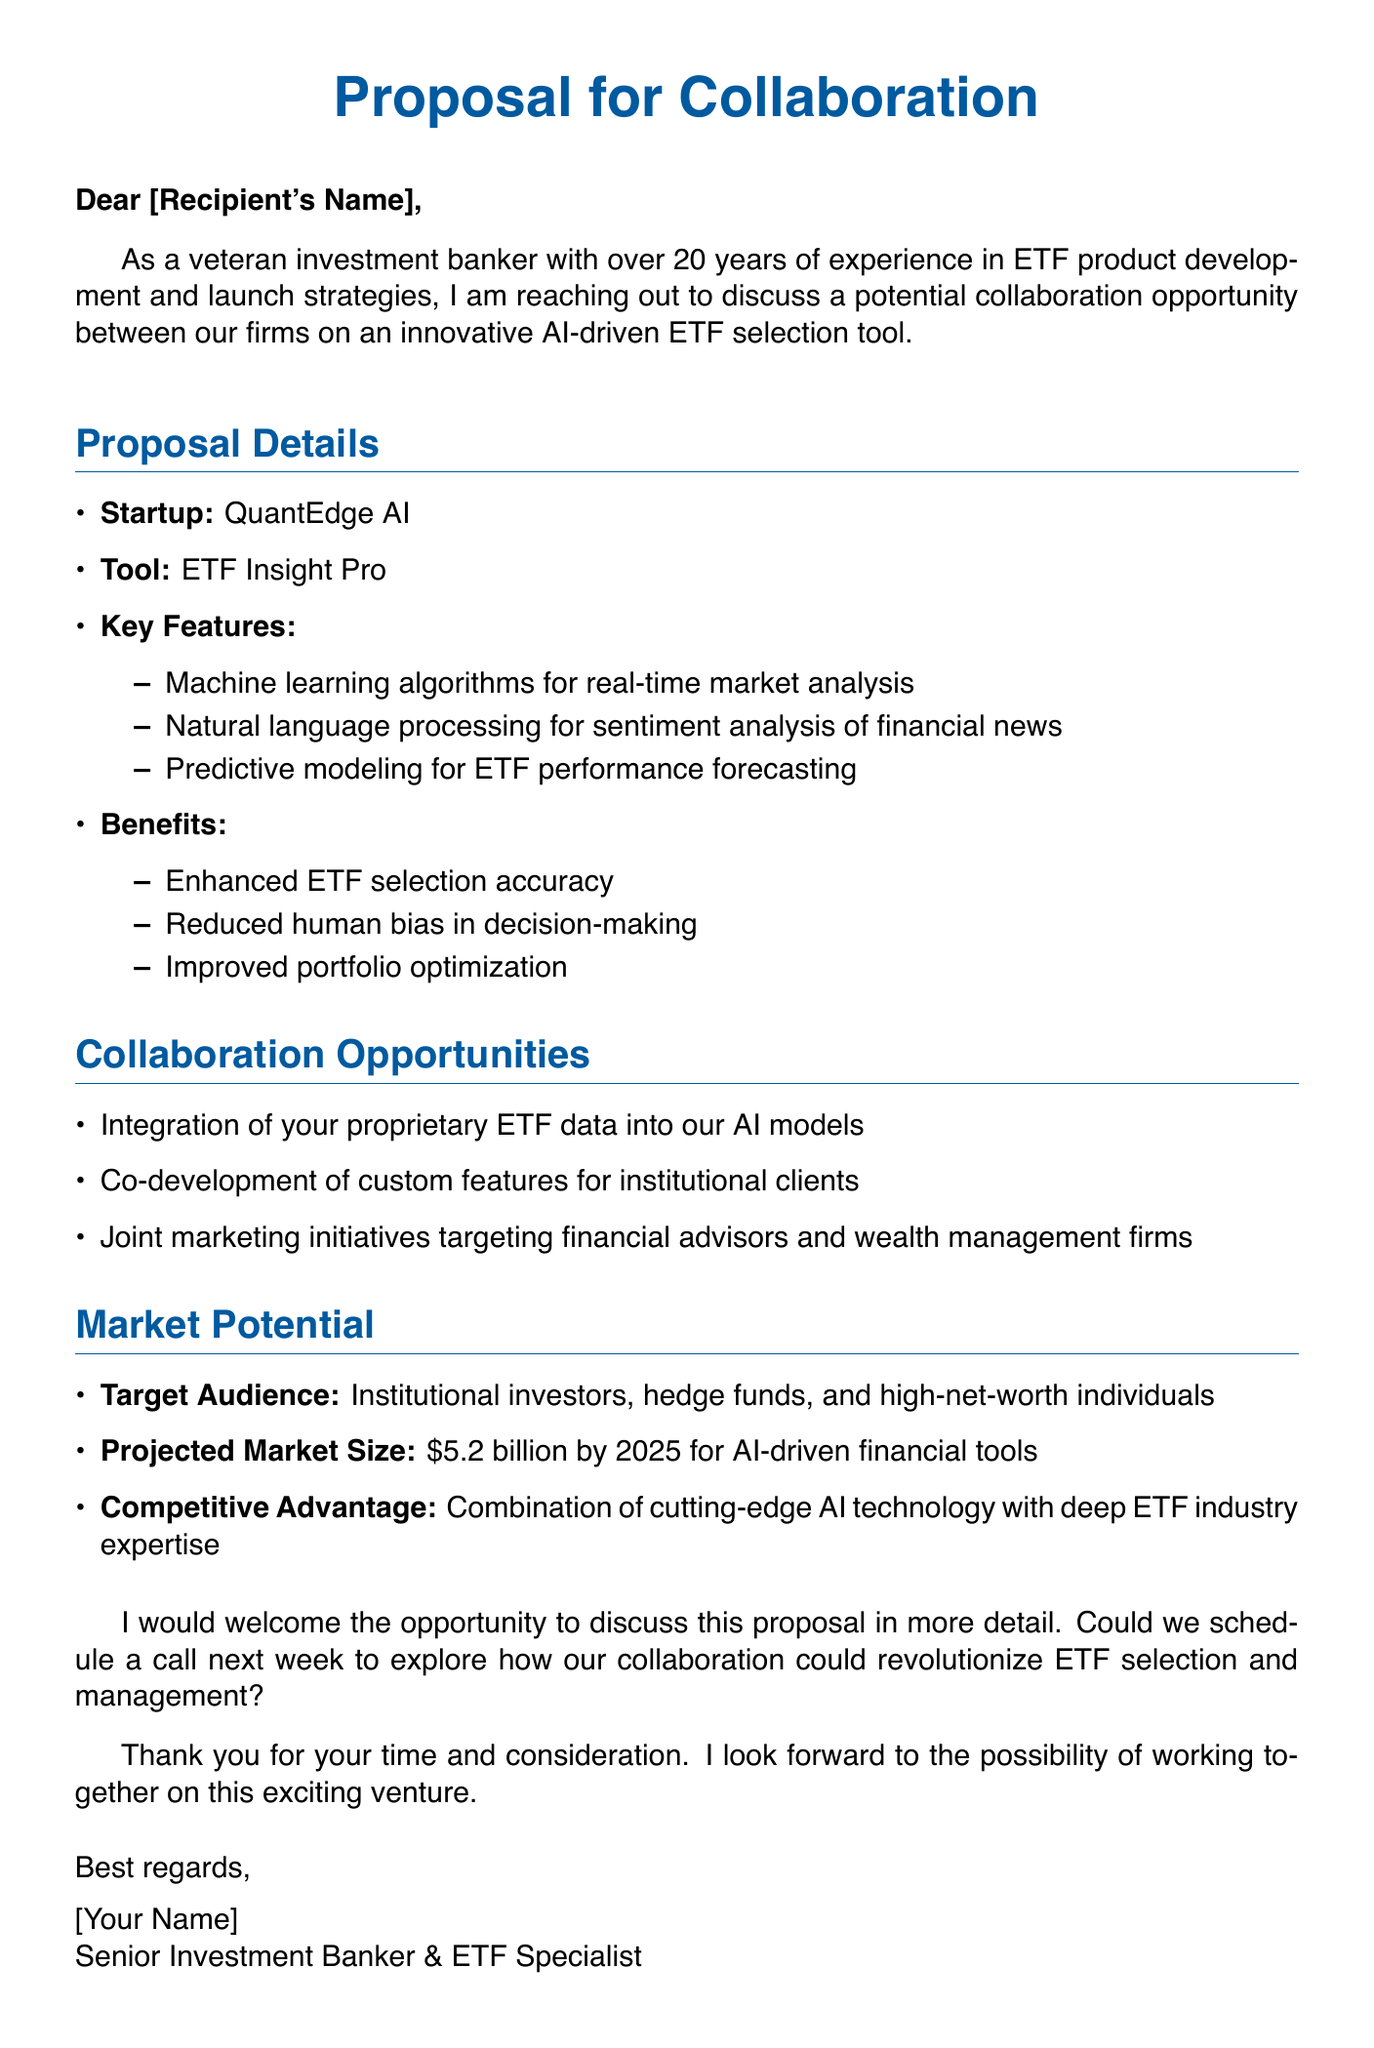What is the name of the startup? The startup's name is mentioned in the proposal details section.
Answer: QuantEdge AI What is the primary tool discussed in the proposal? The tool's name is stated under proposal details.
Answer: ETF Insight Pro What are the projected market size and year? The projected market size is mentioned in the market potential section, along with the target year.
Answer: $5.2 billion by 2025 How many key features are listed for the tool? The number of key features is derived from the bullet points under the key features section.
Answer: Three Which technology is used for sentiment analysis? The specific technology mentioned for sentiment analysis is found in the key features section.
Answer: Natural language processing What collaboration opportunity involves proprietary ETF data? The proposal details a specific collaboration opportunity regarding data integration.
Answer: Integration of your proprietary ETF data into our AI models Who is the target audience for the tool? The target audience is specified in the market potential section of the document.
Answer: Institutional investors, hedge funds, and high-net-worth individuals What is the main benefit of reducing human bias? The benefit related to reduced human bias is discussed in the benefits section.
Answer: Reduced human bias in decision-making What is the sender's title? The sender's title is found in the closing signature at the end of the document.
Answer: Senior Investment Banker & ETF Specialist 